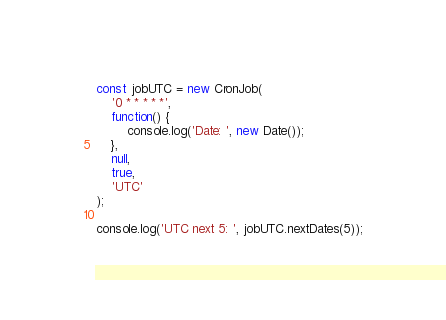Convert code to text. <code><loc_0><loc_0><loc_500><loc_500><_JavaScript_>
const jobUTC = new CronJob(
	'0 * * * * *',
	function() {
		console.log('Date: ', new Date());
	},
	null,
	true,
	'UTC'
);

console.log('UTC next 5: ', jobUTC.nextDates(5));
</code> 